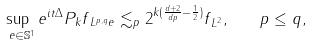Convert formula to latex. <formula><loc_0><loc_0><loc_500><loc_500>\sup _ { \ e \in \mathbb { S } ^ { 1 } } \| e ^ { i t \Delta } P _ { k } f \| _ { L ^ { p , q } _ { \ } e } \lesssim _ { p } 2 ^ { k ( \frac { d + 2 } { d p } - \frac { 1 } { 2 } ) } \| f \| _ { L ^ { 2 } } , \quad p \leq q ,</formula> 